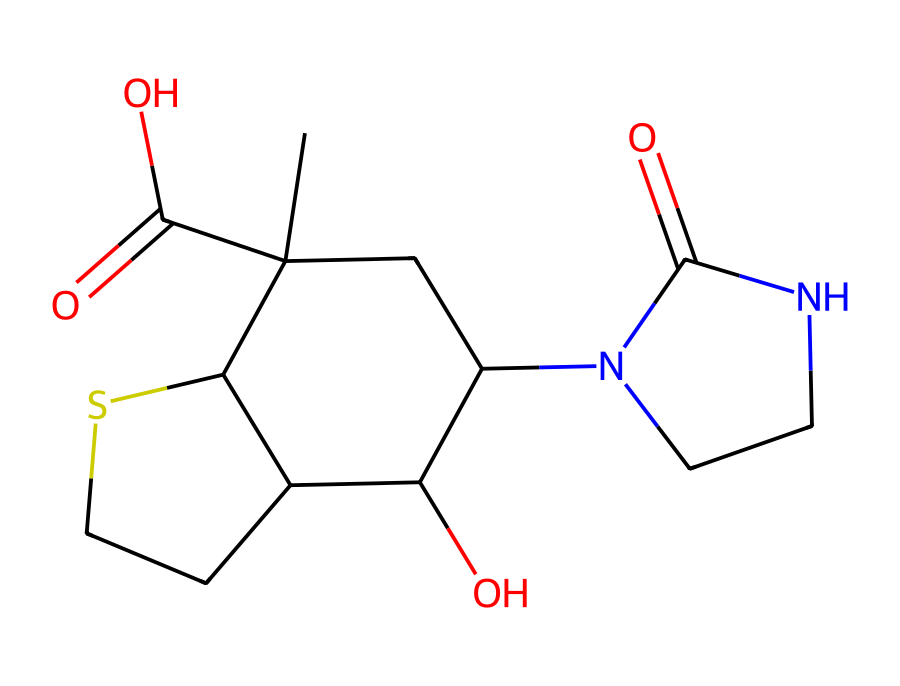What is the molecular formula of biotin? By analyzing the SMILES representation, we can deduce the number of each type of atom present. The components include carbon (C), hydrogen (H), nitrogen (N), oxygen (O), and sulfur (S). Counting gives us C10, H16, N2, O3, and S.
Answer: C10H16N2O3S How many rings are present in the structure of biotin? Looking closely at the structural representation, we can see that biotin includes one cyclic structure, indicated by the presence of carbon atoms arranged in a ring formation.
Answer: 1 What functional group is present that indicates it's a carboxylic acid? The presence of a -COOH group in the chemical structure indicates that biotin contains a carboxylic acid functional group. This is observed in the last part of the molecule.
Answer: -COOH Which element in biotin contributes to its classification as an organosulfur compound? Biotin contains a sulfur atom (S), which is crucial for it to be classified as an organosulfur compound. The specific sulfur atom's presence in the molecule highlights this classification.
Answer: sulfur What roles do the nitrogen atoms play in the structure of biotin? The nitrogen atoms in biotin are part of amide groups, which contribute to the molecular stability and also assist in biochemical interactions necessary for its function as a vitamin.
Answer: stability and interaction How many oxygen atoms are in biotin? Directly counting from the SMILES string representation shows there are three oxygen atoms contributing to various functional groups in the biotin structure.
Answer: 3 What property of biotin is associated with the presence of the sulfur atom? The inclusion of sulfur in biotin contributes to its role in various biochemical processes, such as supporting hair and nail health. This property is significant due to the essential roles sulfur plays in protein structures and metabolic functions.
Answer: health function 